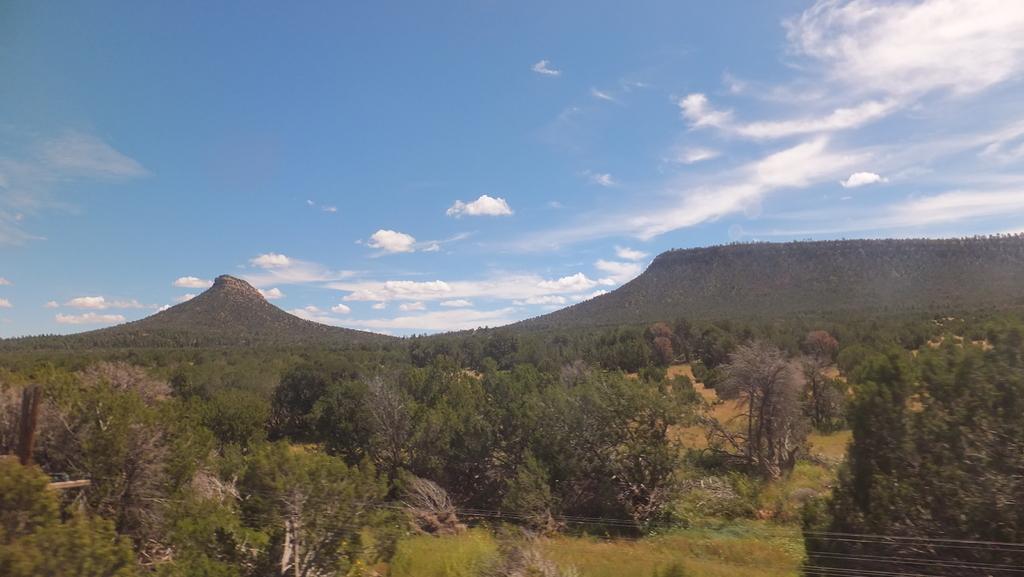Describe this image in one or two sentences. To the bottom of the image there is a grass and also few plants and trees are on the ground. In the background there are hills with trees on it. To the top of the image there heels with plants. And to the top of the image there is a blue sky with white clouds. 